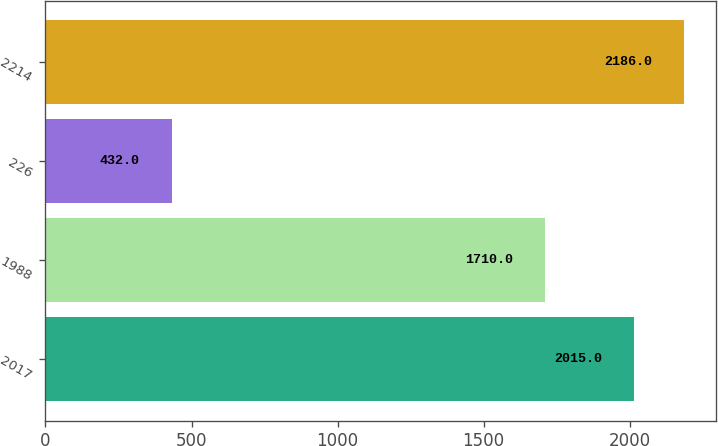Convert chart to OTSL. <chart><loc_0><loc_0><loc_500><loc_500><bar_chart><fcel>2017<fcel>1988<fcel>226<fcel>2214<nl><fcel>2015<fcel>1710<fcel>432<fcel>2186<nl></chart> 